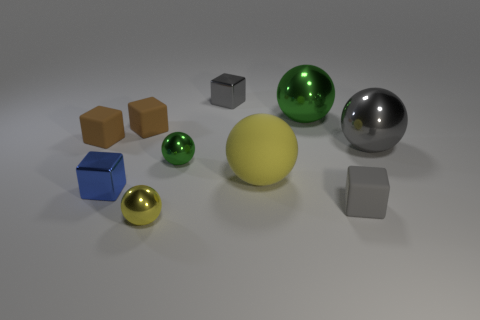Subtract all matte balls. How many balls are left? 4 Subtract 4 balls. How many balls are left? 1 Subtract all gray balls. How many balls are left? 4 Add 6 gray rubber objects. How many gray rubber objects exist? 7 Subtract 0 red cubes. How many objects are left? 10 Subtract all brown spheres. Subtract all blue blocks. How many spheres are left? 5 Subtract all blue balls. How many brown cubes are left? 2 Subtract all large red metallic things. Subtract all small blue shiny cubes. How many objects are left? 9 Add 1 metal things. How many metal things are left? 7 